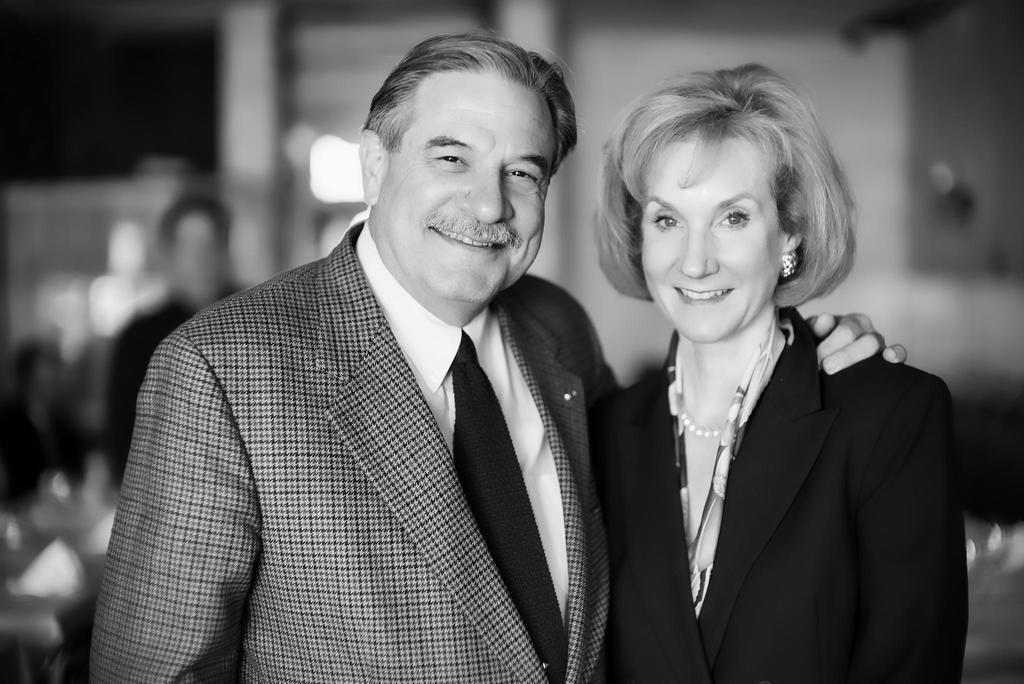What is the color scheme of the image? The image is black and white. How many people are in the image? There are two people in the image: a man and a woman. What are the man and the woman wearing? Both the man and the woman are wearing suits. Can you describe the background of the image? There is a person in the background of the image, along with tables and chairs. Is there a sofa in the background of the image? No, there is no sofa present in the image. Is the man lifting the woman in the image? No, the man and the woman are both standing next to each other, and there is no indication of them lifting or moving in any way. 